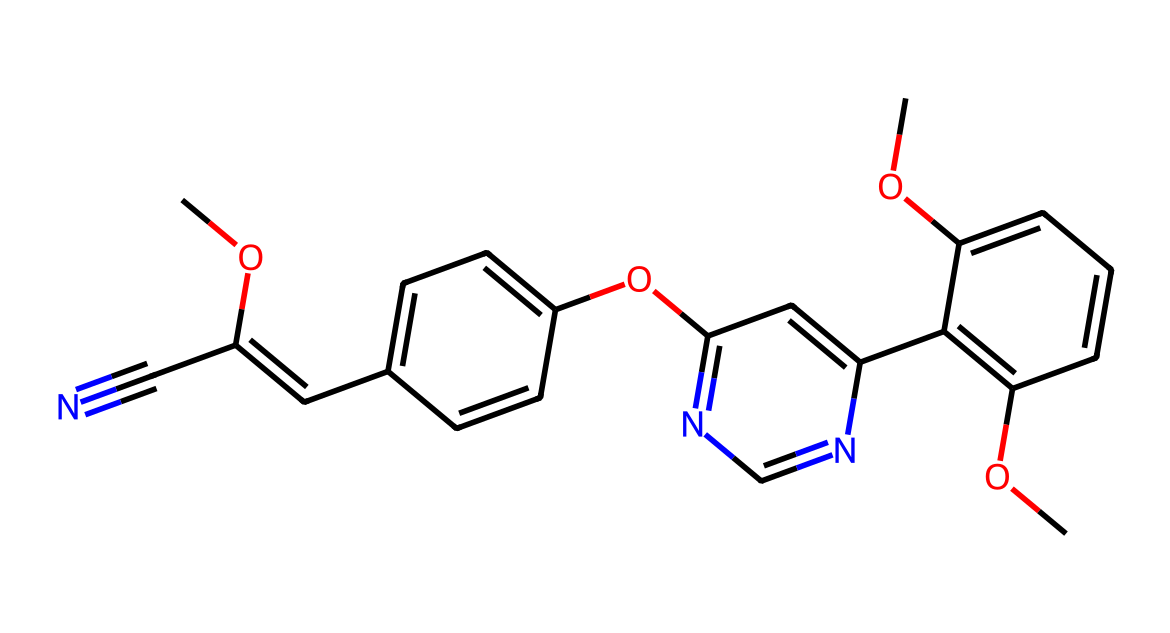What is the molecular formula of azoxystrobin? By analyzing the structure given in the SMILES representation, we can compute the elements present: carbon (C), hydrogen (H), oxygen (O), and nitrogen (N). The counts contribute to the molecular formula as C18H18N4O5.
Answer: C18H18N4O5 How many nitrogen atoms are present in this compound? From the SMILES representation, the nitrogen atoms are denoted by the letter 'N.' Counting the occurrences within the structure reveals there are 4 nitrogen atoms.
Answer: 4 What type of functional groups are present in azoxystrobin? Observing the structure in the SMILES, we find functional groups such as methoxy (-OCH3), cyano (-C#N), and a heterocyclic structure visible in the azole rings. This indicates multiple functional groups are present.
Answer: methoxy, cyano, heterocyclic rings Is azoxystrobin a broad-spectrum fungicide? The chemical structure shows multiple benzene rings and substituents that often contribute to broader activity against fungi. Azoxystrobin is indeed categorized as a broad-spectrum fungicide based on its chemical design and effectiveness.
Answer: yes What is the role of the cyano group in azoxystrobin? The cyano group (-C#N) is known to enhance the biological activity of the fungicide through its electron-withdrawing properties, favoring interaction with the target proteins in fungal cells.
Answer: enhance activity How many aromatic rings does azoxystrobin contain? By examining the structure within the SMILES representation, we identify multiple cycles, specifically focusing on those that contain alternating double bonds; there are three distinct aromatic rings present in azoxystrobin.
Answer: 3 What is the significance of the methoxy groups in azoxystrobin? Methoxy groups (-OCH3) improve the lipophilicity of the compound, aiding in its penetration through cell membranes and increasing its efficacy as a fungicide. Therefore, methoxy groups are crucial for its performance.
Answer: improve lipophilicity 